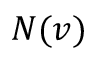Convert formula to latex. <formula><loc_0><loc_0><loc_500><loc_500>N ( v )</formula> 